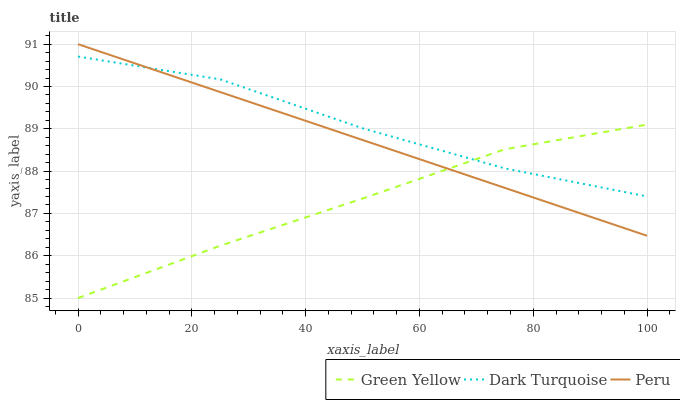Does Peru have the minimum area under the curve?
Answer yes or no. No. Does Peru have the maximum area under the curve?
Answer yes or no. No. Is Green Yellow the smoothest?
Answer yes or no. No. Is Green Yellow the roughest?
Answer yes or no. No. Does Peru have the lowest value?
Answer yes or no. No. Does Green Yellow have the highest value?
Answer yes or no. No. 